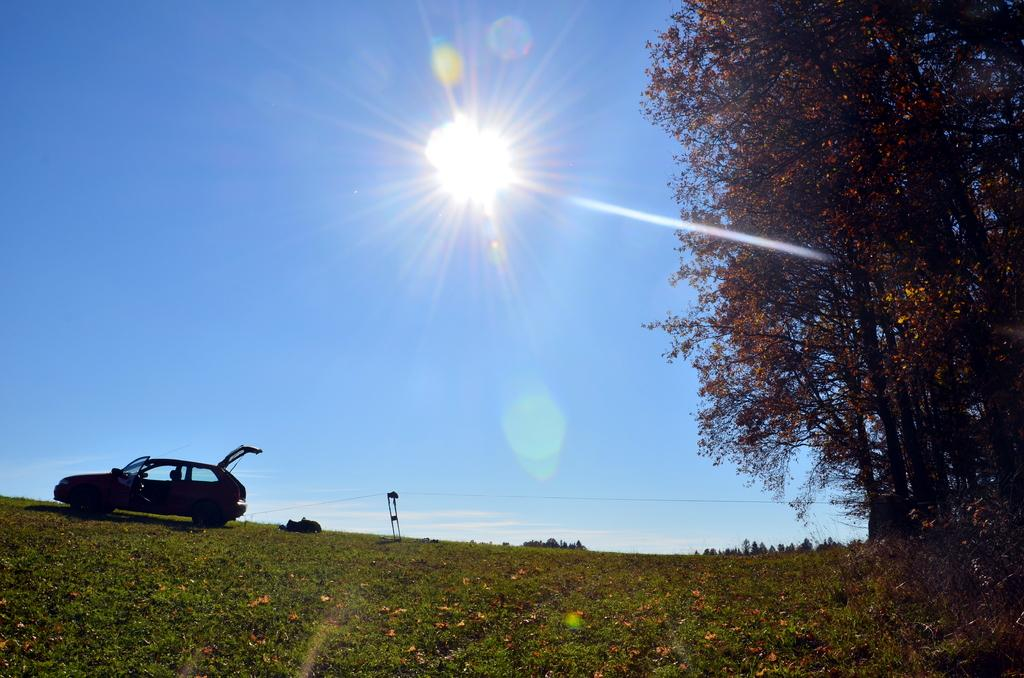What type of surface is visible in the image? There is a grass surface in the image. What can be seen on the grass surface? There is a car with the doors opened in the image. What is located next to the car? There is a tree next to the car in the image. What is visible in the background of the image? The sky is visible in the background of the image. Can the sun be seen in the sky? Yes, the sun is observable in the sky. What news is being broadcasted from the car in the image? There is no indication in the image that the car is broadcasting any news. Can you see a squirrel climbing the tree next to the car in the image? There is no squirrel visible in the image; only the car, tree, and grass surface are present. 